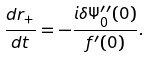Convert formula to latex. <formula><loc_0><loc_0><loc_500><loc_500>\frac { d { r } _ { + } } { d t } = - \frac { i \delta \Psi _ { 0 } ^ { \prime \prime } ( 0 ) } { f ^ { \prime } ( 0 ) } .</formula> 